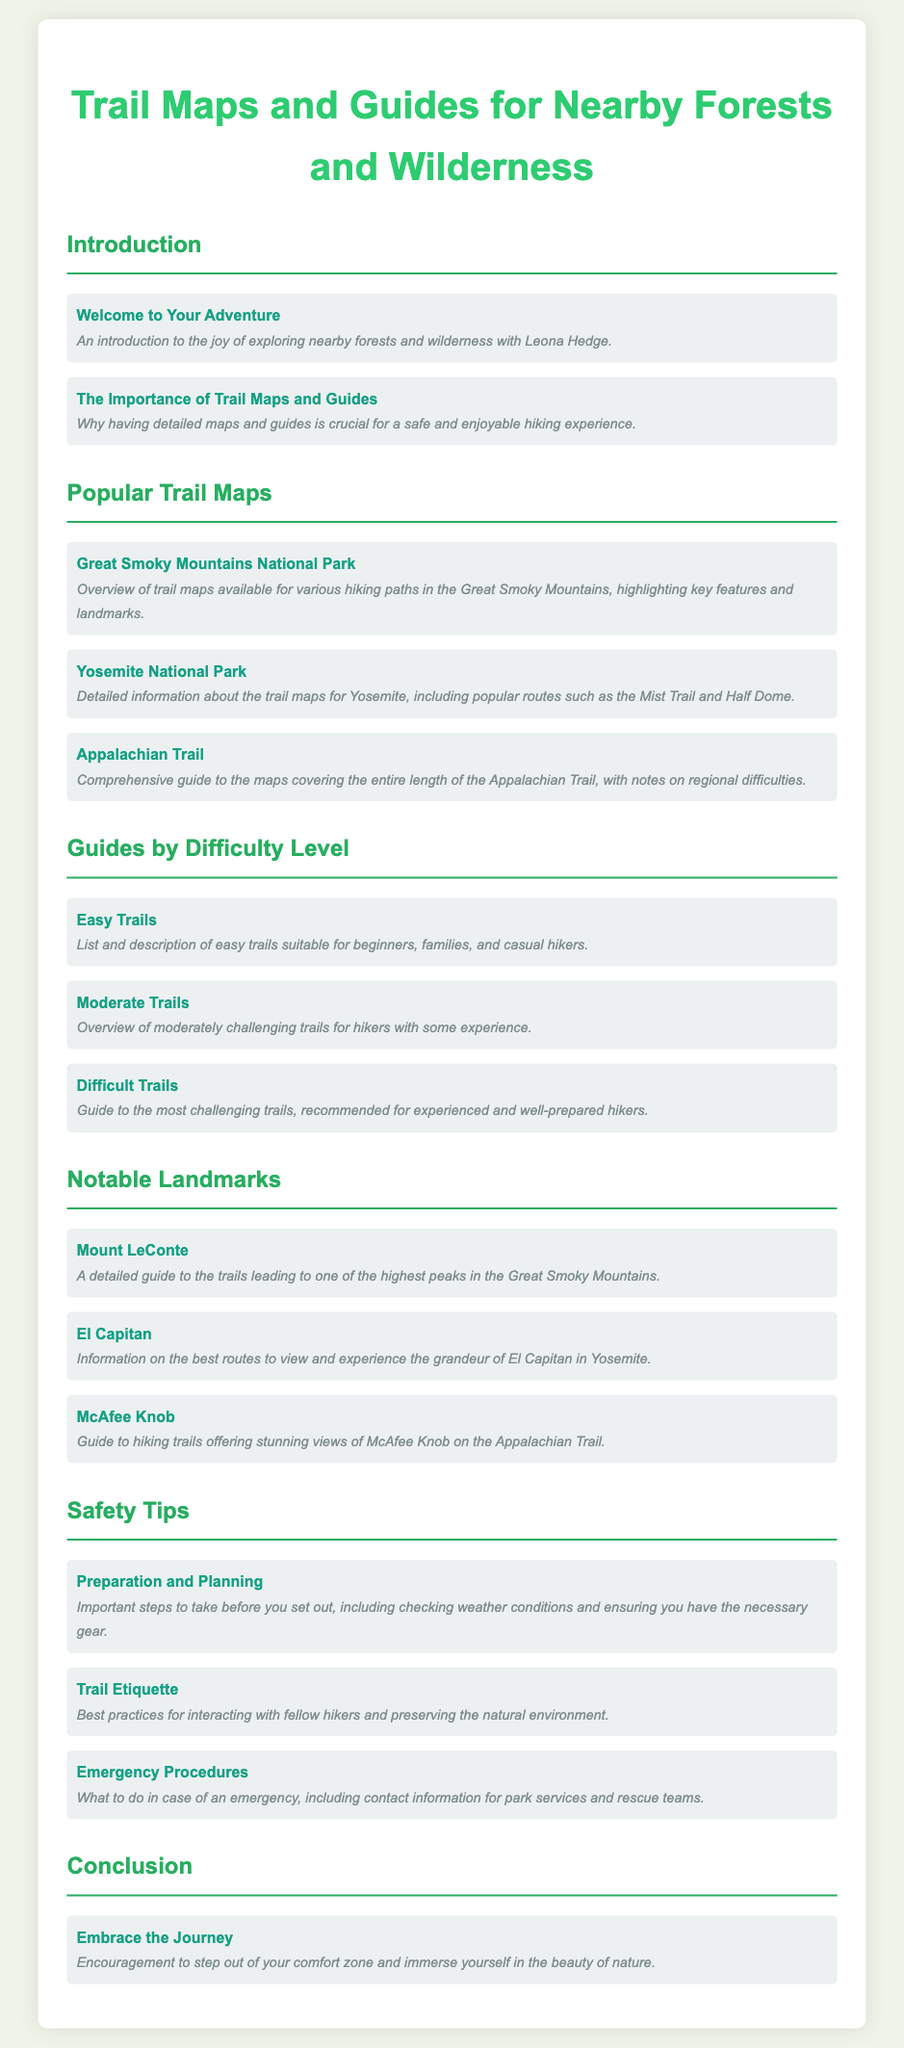What is the title of the document? The title is found at the top of the rendered document, introducing the audience to the main theme.
Answer: Trail Maps and Guides for Nearby Forests and Wilderness How many sections are there in the document? The document contains multiple sections, each addressing a specific aspect of trail maps and guides.
Answer: 6 What does the first section discuss? The first section provides an introductory overview related to trail maps and the enjoyment of nature exploration.
Answer: Welcome to Your Adventure Which national park is mentioned in the second section? The document specifies popular trails and maps for renowned parks to assist hikers in planning their adventures.
Answer: Yosemite National Park What type of trails are listed under 'Guides by Difficulty Level'? The document categorizes trails based on their complexity, offering hikers guidance based on their experience.
Answer: Easy, Moderate, Difficult Who is Mount LeConte associated with? The document highlights notable landmarks connected to specific trails, offering detailed context for hikers.
Answer: Great Smoky Mountains What is emphasized in the 'Safety Tips' section? This section outlines crucial practices to ensure a safe and responsible hiking experience in the wilderness.
Answer: Preparation and Planning What should you do in case of an emergency? The document provides essential guidance for hikers in distress, ensuring they know how to seek assistance.
Answer: Contact information for park services What is the final encouragement given to readers? The conclusion seeks to inspire readers to engage deeply with the natural world around them.
Answer: Embrace the Journey 